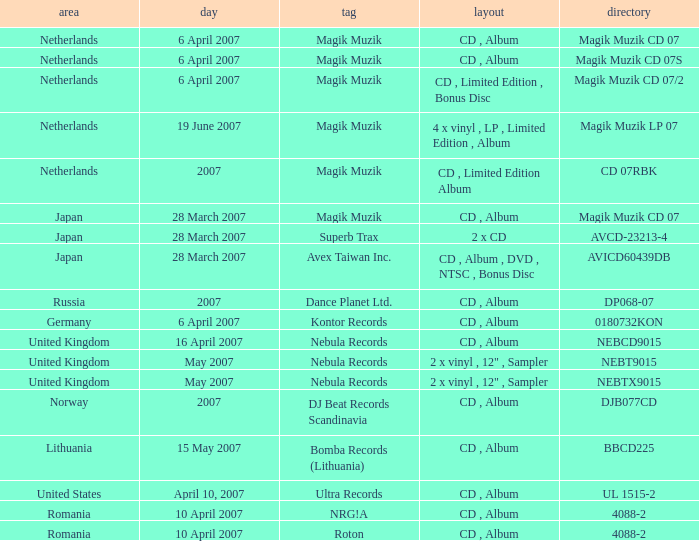From which region is the album with release date of 19 June 2007? Netherlands. 